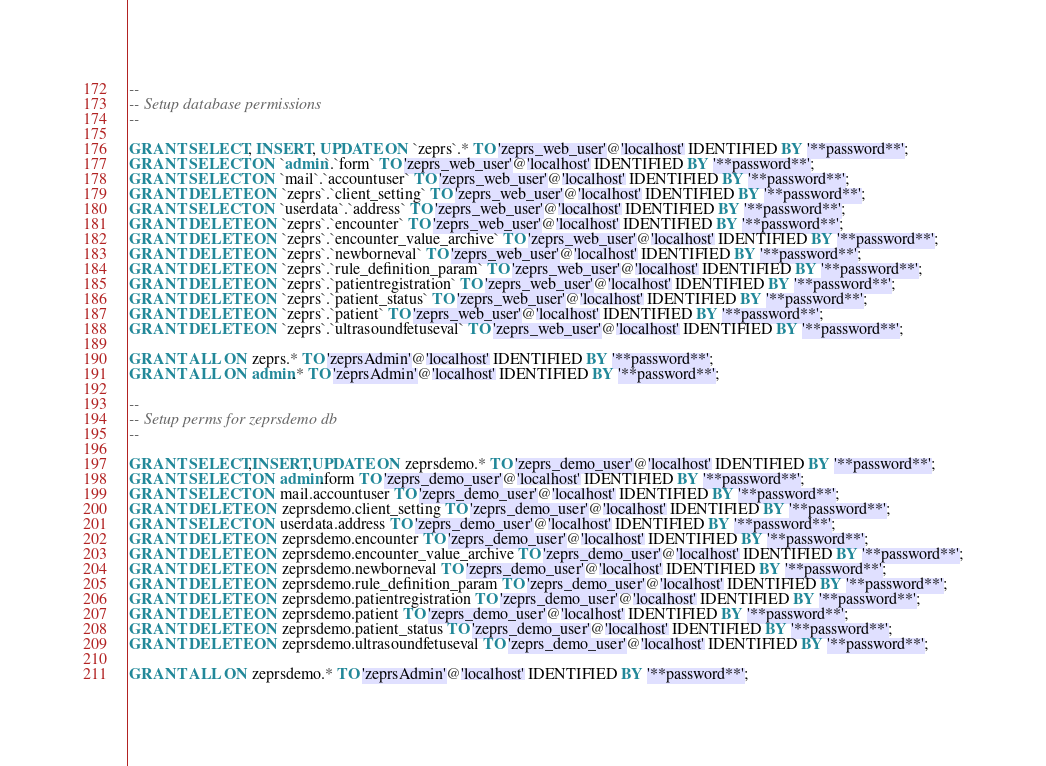<code> <loc_0><loc_0><loc_500><loc_500><_SQL_>--
-- Setup database permissions
--

GRANT SELECT, INSERT, UPDATE ON `zeprs`.* TO 'zeprs_web_user'@'localhost' IDENTIFIED BY '**password**';
GRANT SELECT ON `admin`.`form` TO 'zeprs_web_user'@'localhost' IDENTIFIED BY '**password**';
GRANT SELECT ON `mail`.`accountuser` TO 'zeprs_web_user'@'localhost' IDENTIFIED BY '**password**';
GRANT DELETE ON `zeprs`.`client_setting` TO 'zeprs_web_user'@'localhost' IDENTIFIED BY '**password**';
GRANT SELECT ON `userdata`.`address` TO 'zeprs_web_user'@'localhost' IDENTIFIED BY '**password**';
GRANT DELETE ON `zeprs`.`encounter` TO 'zeprs_web_user'@'localhost' IDENTIFIED BY '**password**';
GRANT DELETE ON `zeprs`.`encounter_value_archive` TO 'zeprs_web_user'@'localhost' IDENTIFIED BY '**password**';
GRANT DELETE ON `zeprs`.`newborneval` TO 'zeprs_web_user'@'localhost' IDENTIFIED BY '**password**';
GRANT DELETE ON `zeprs`.`rule_definition_param` TO 'zeprs_web_user'@'localhost' IDENTIFIED BY '**password**';
GRANT DELETE ON `zeprs`.`patientregistration` TO 'zeprs_web_user'@'localhost' IDENTIFIED BY '**password**';
GRANT DELETE ON `zeprs`.`patient_status` TO 'zeprs_web_user'@'localhost' IDENTIFIED BY '**password**';
GRANT DELETE ON `zeprs`.`patient` TO 'zeprs_web_user'@'localhost' IDENTIFIED BY '**password**';
GRANT DELETE ON `zeprs`.`ultrasoundfetuseval` TO 'zeprs_web_user'@'localhost' IDENTIFIED BY '**password**';

GRANT ALL ON zeprs.* TO 'zeprsAdmin'@'localhost' IDENTIFIED BY '**password**';
GRANT ALL ON admin.* TO 'zeprsAdmin'@'localhost' IDENTIFIED BY '**password**';

--
-- Setup perms for zeprsdemo db
--

GRANT SELECT,INSERT,UPDATE ON zeprsdemo.* TO 'zeprs_demo_user'@'localhost' IDENTIFIED BY '**password**';
GRANT SELECT ON admin.form TO 'zeprs_demo_user'@'localhost' IDENTIFIED BY '**password**';
GRANT SELECT ON mail.accountuser TO 'zeprs_demo_user'@'localhost' IDENTIFIED BY '**password**';
GRANT DELETE ON zeprsdemo.client_setting TO 'zeprs_demo_user'@'localhost' IDENTIFIED BY '**password**';
GRANT SELECT ON userdata.address TO 'zeprs_demo_user'@'localhost' IDENTIFIED BY '**password**';
GRANT DELETE ON zeprsdemo.encounter TO 'zeprs_demo_user'@'localhost' IDENTIFIED BY '**password**';
GRANT DELETE ON zeprsdemo.encounter_value_archive TO 'zeprs_demo_user'@'localhost' IDENTIFIED BY '**password**';
GRANT DELETE ON zeprsdemo.newborneval TO 'zeprs_demo_user'@'localhost' IDENTIFIED BY '**password**';
GRANT DELETE ON zeprsdemo.rule_definition_param TO 'zeprs_demo_user'@'localhost' IDENTIFIED BY '**password**';
GRANT DELETE ON zeprsdemo.patientregistration TO 'zeprs_demo_user'@'localhost' IDENTIFIED BY '**password**';
GRANT DELETE ON zeprsdemo.patient TO 'zeprs_demo_user'@'localhost' IDENTIFIED BY '**password**';
GRANT DELETE ON zeprsdemo.patient_status TO 'zeprs_demo_user'@'localhost' IDENTIFIED BY '**password**';
GRANT DELETE ON zeprsdemo.ultrasoundfetuseval TO 'zeprs_demo_user'@'localhost' IDENTIFIED BY '**password**';

GRANT ALL ON zeprsdemo.* TO 'zeprsAdmin'@'localhost' IDENTIFIED BY '**password**';



</code> 